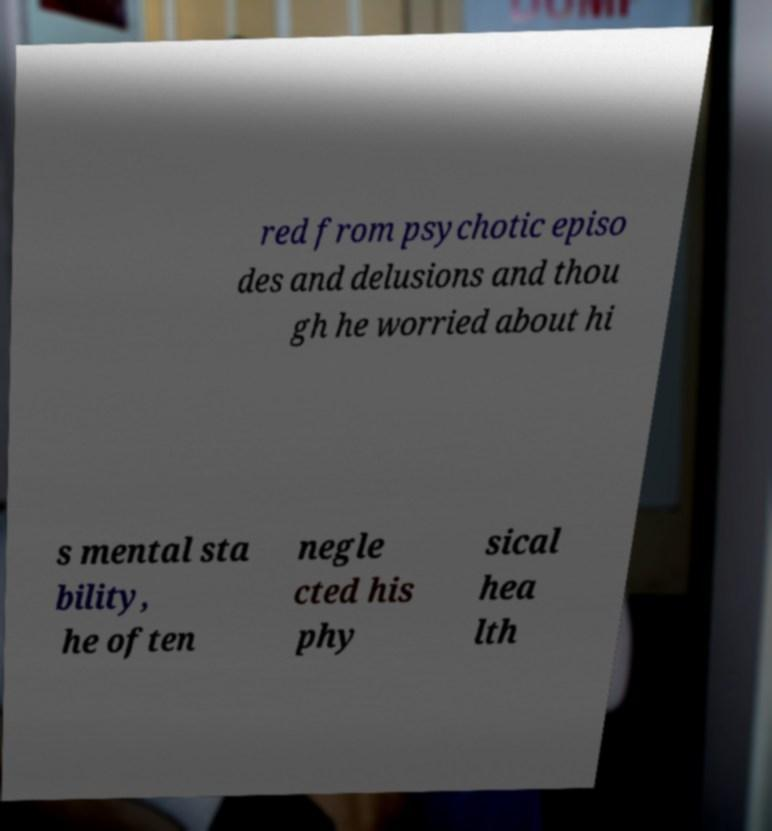Can you read and provide the text displayed in the image?This photo seems to have some interesting text. Can you extract and type it out for me? red from psychotic episo des and delusions and thou gh he worried about hi s mental sta bility, he often negle cted his phy sical hea lth 